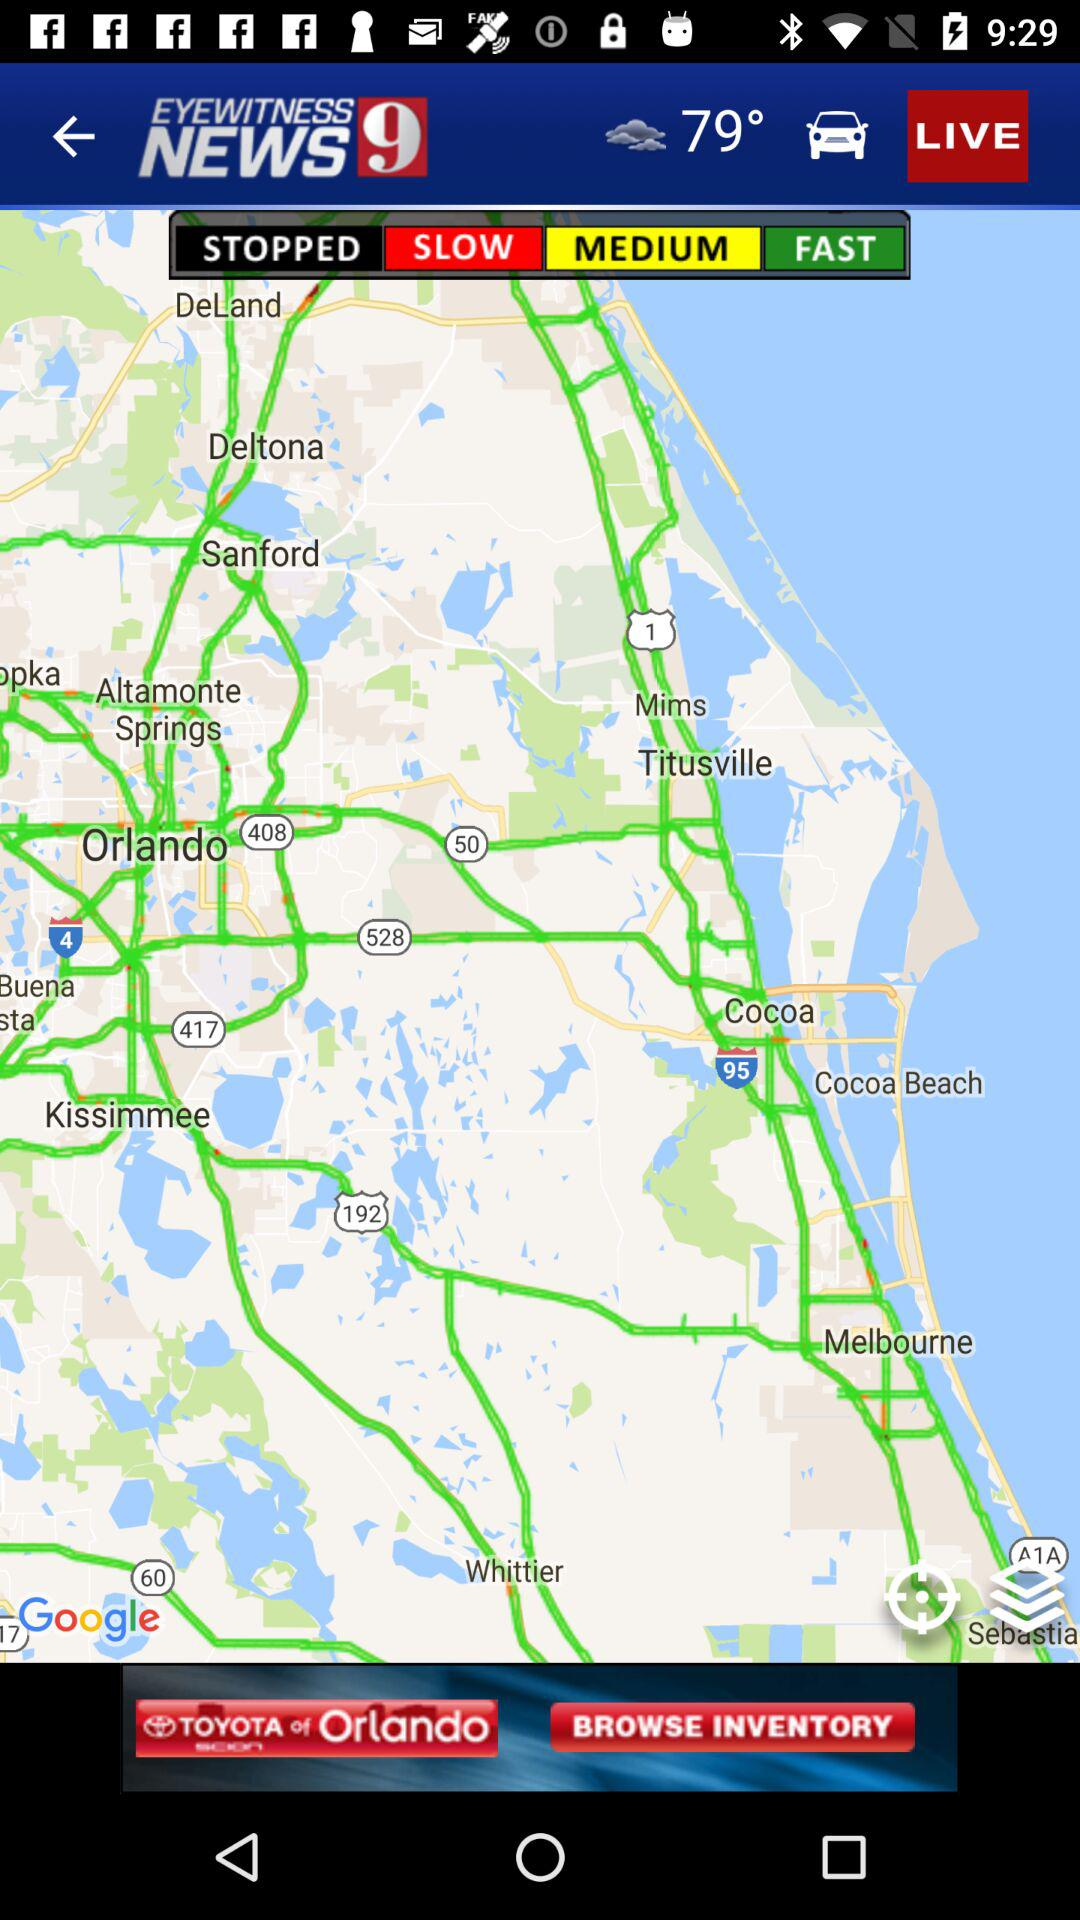What is the name of the application? The name of the application is "WFTV Channel 9 Eyewitness News". 